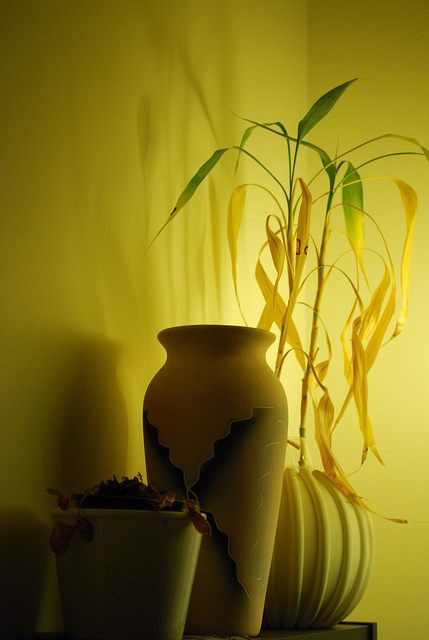<image>What kind of plant is this? I don't know what kind of plant this is. It could be weeds, bamboo, fern, corn, or a dying schefflera. What kind of plant is this? I don't know what kind of plant this is. It could be weeds, bamboo, fern or corn. 